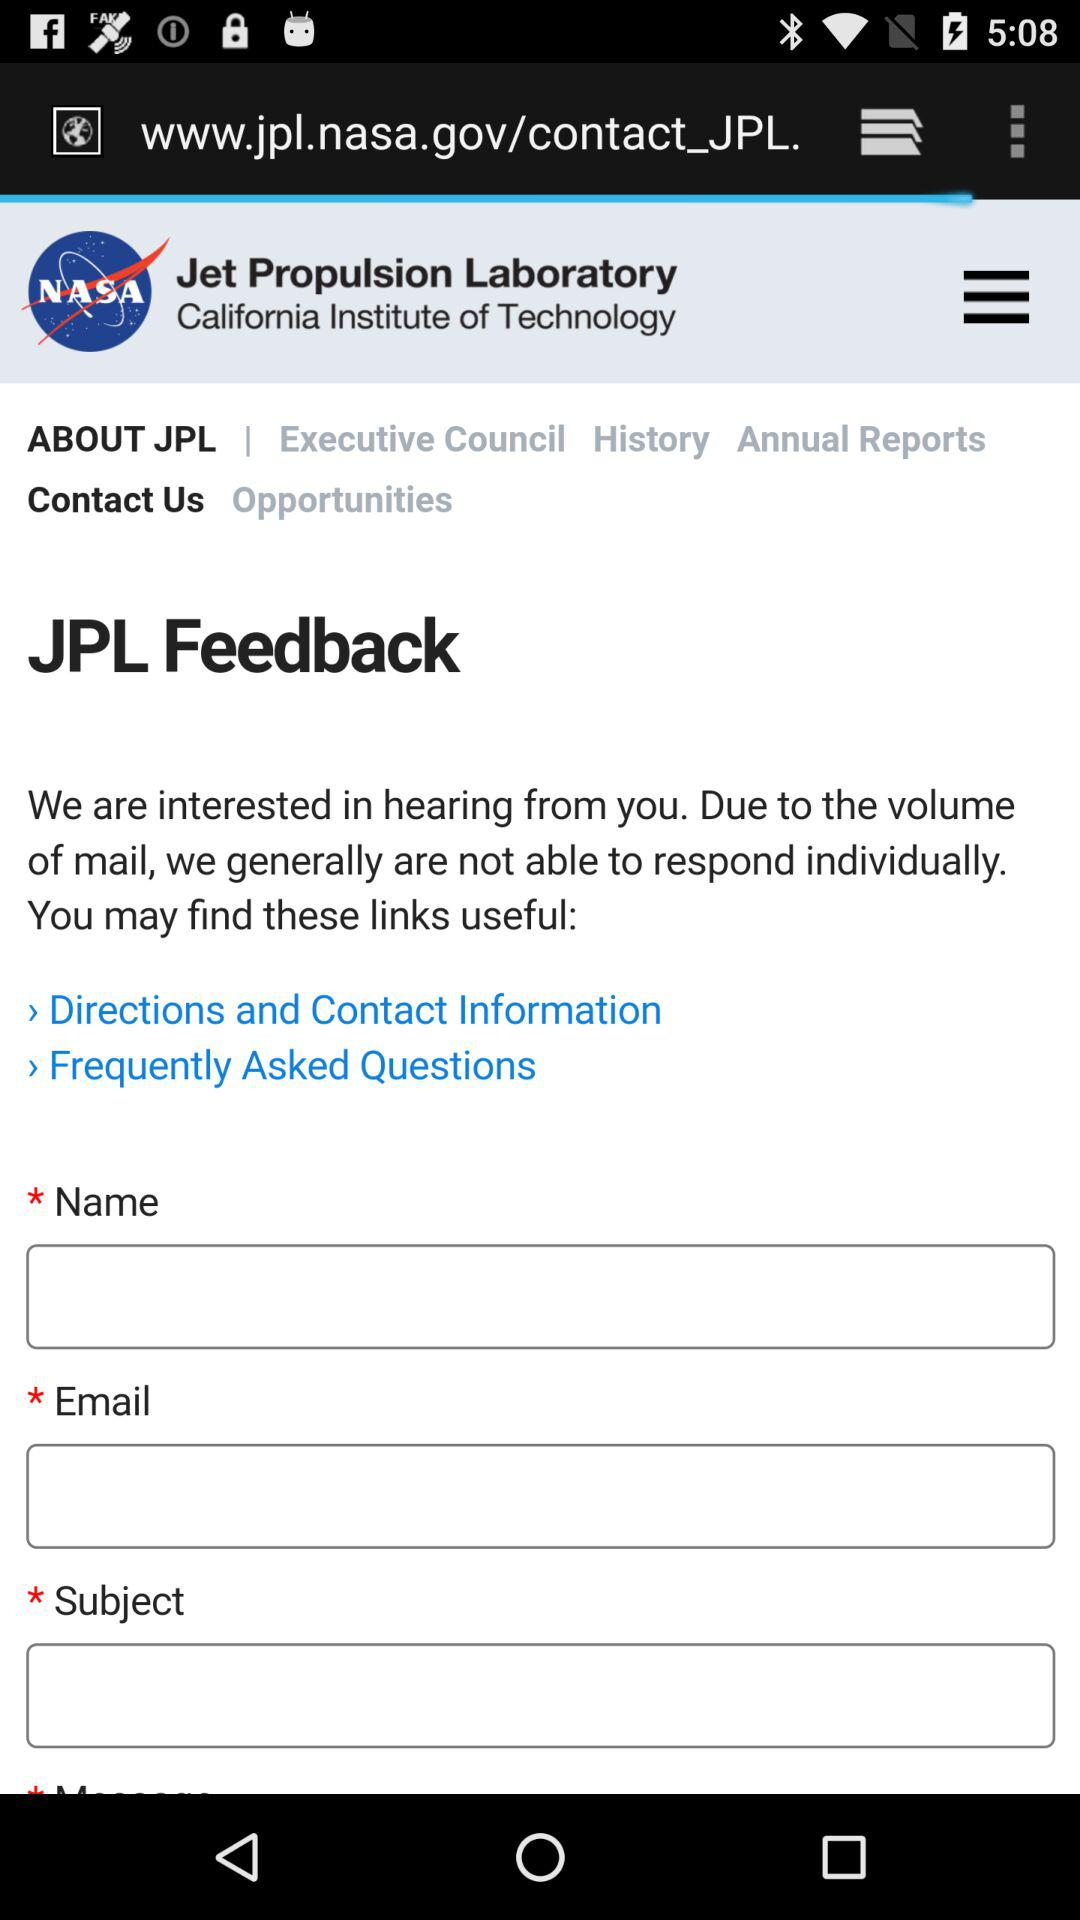Where is the laboratory situated? The laboratory is situated at the "California Institute of Technology". 